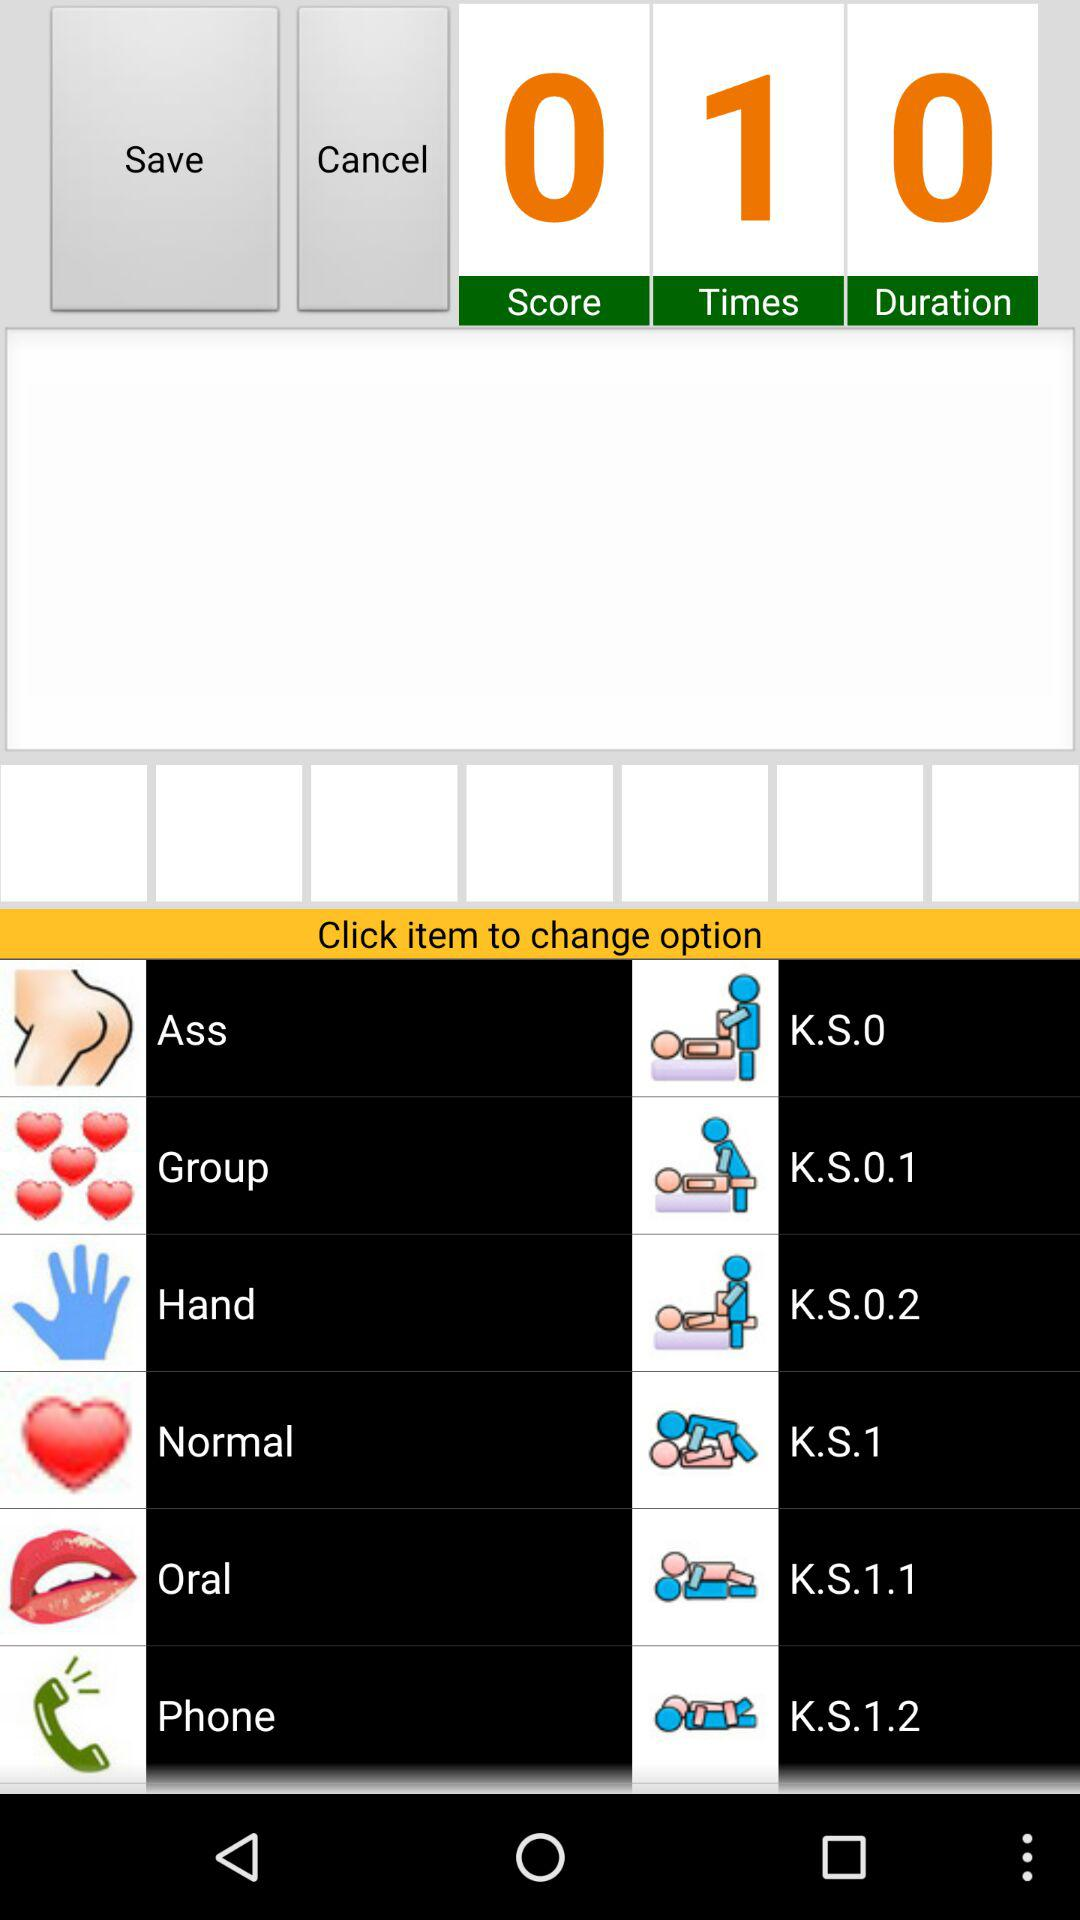How much is the duration? The duration is 0. 